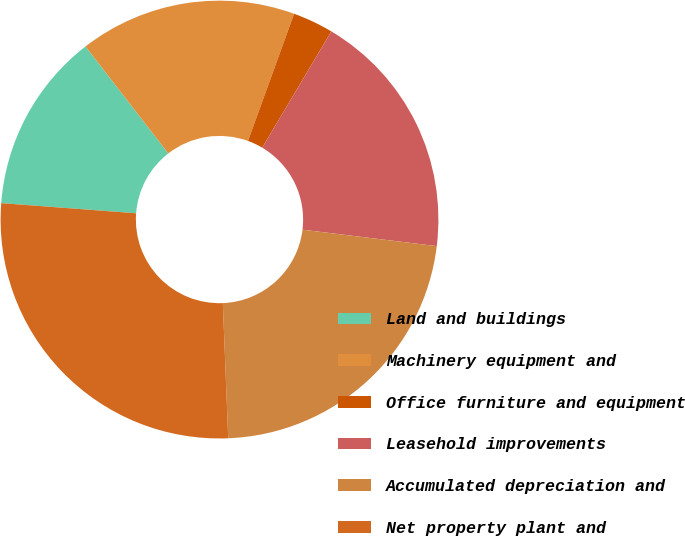<chart> <loc_0><loc_0><loc_500><loc_500><pie_chart><fcel>Land and buildings<fcel>Machinery equipment and<fcel>Office furniture and equipment<fcel>Leasehold improvements<fcel>Accumulated depreciation and<fcel>Net property plant and<nl><fcel>13.32%<fcel>16.02%<fcel>3.0%<fcel>18.4%<fcel>22.43%<fcel>26.83%<nl></chart> 